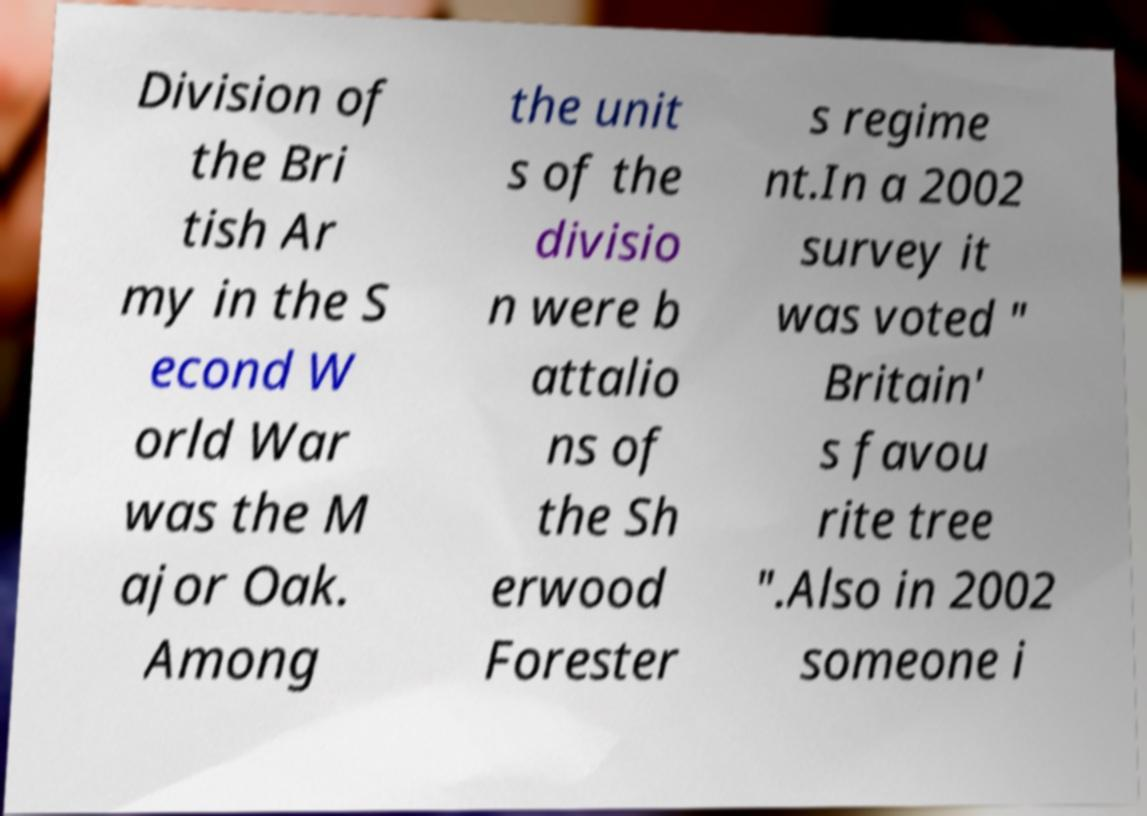Can you read and provide the text displayed in the image?This photo seems to have some interesting text. Can you extract and type it out for me? Division of the Bri tish Ar my in the S econd W orld War was the M ajor Oak. Among the unit s of the divisio n were b attalio ns of the Sh erwood Forester s regime nt.In a 2002 survey it was voted " Britain' s favou rite tree ".Also in 2002 someone i 